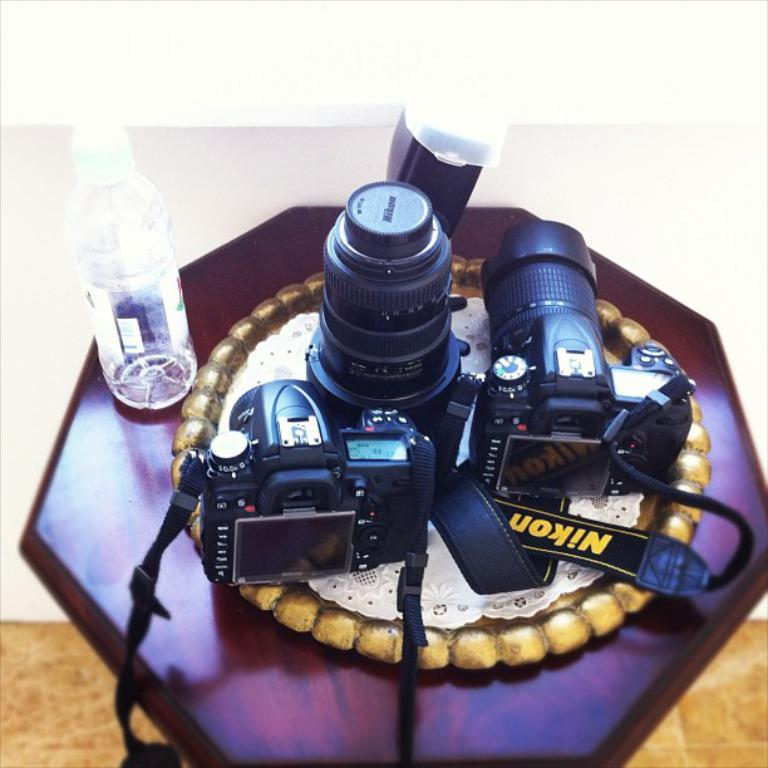Where is the picture taken? The picture is taken on a table. What objects can be seen on the table? There is a bottle, a camera, a plate, and a cloth on the table. What is the color of the wall in the background? The wall in the background is white. What type of doctor is present in the image? There is no doctor present in the image; it features a table with various objects on it. What type of meal is being prepared on the table? There is no meal being prepared on the table; the image only shows a bottle, a camera, a plate, and a cloth. 